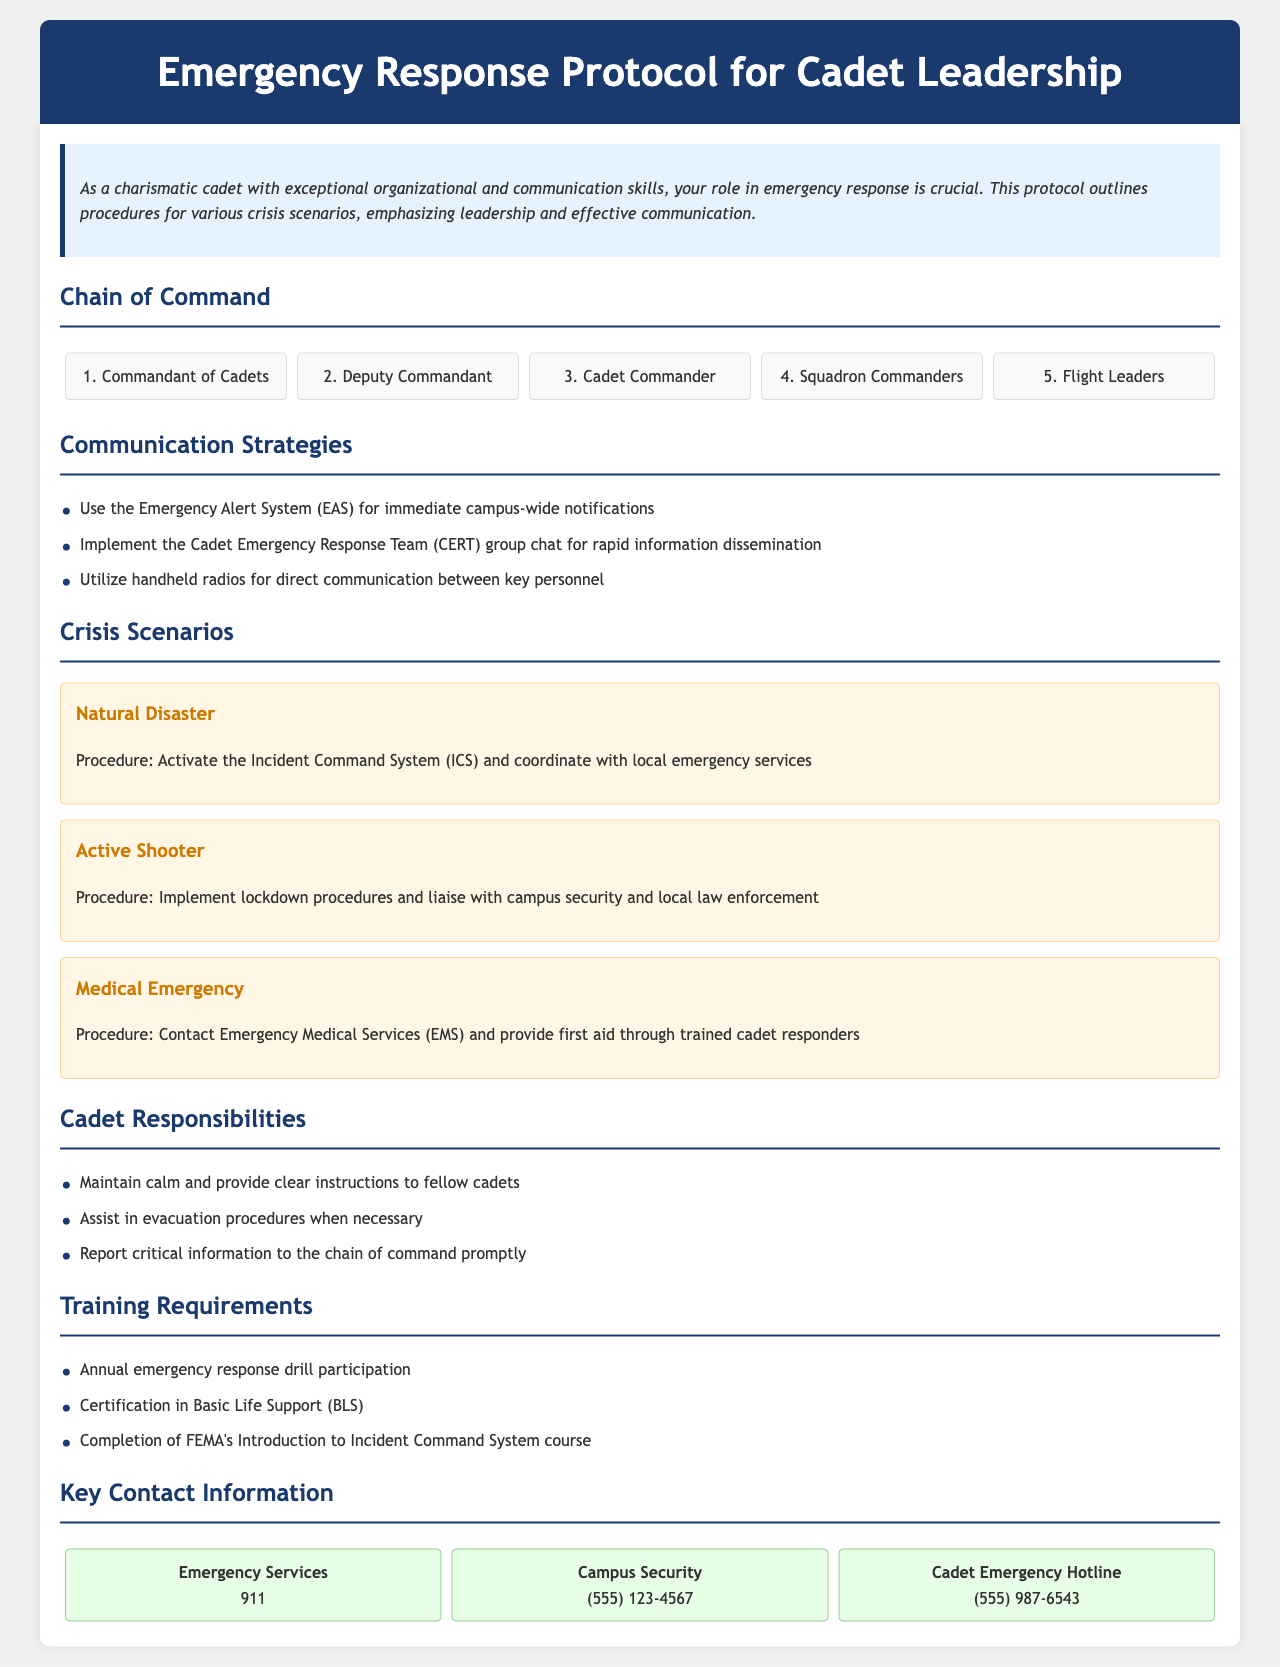What is the title of the document? The title of the document can be found in the header section of the document.
Answer: Emergency Response Protocol for Cadet Leadership How many levels are in the chain of command? The chain of command section lists five distinct positions.
Answer: 5 What is the procedure for a natural disaster? The document specifies the procedure that involves activating the Incident Command System and coordinating with local emergency services.
Answer: Activate ICS and coordinate with local emergency services Which communication strategy involves the Emergency Alert System? The document outlines the use of the EAS for immediate notifications.
Answer: Use the Emergency Alert System (EAS) What responsibility do cadets have during an emergency? The document mentions that cadets must maintain calm and provide clear instructions.
Answer: Maintain calm and provide clear instructions Which organization must cadets complete a course from as part of their training requirements? The document states cadets must complete FEMA's Introduction to Incident Command System course.
Answer: FEMA What is the phone number for campus security? The contact information section provides a specific number for campus security.
Answer: (555) 123-4567 What is the first contact listed under key contact information? The key contact information section lists Emergency Services as the first entry.
Answer: Emergency Services What scenario requires contacting Emergency Medical Services? Medical emergencies necessitate contacting EMS according to the protocol.
Answer: Medical Emergency 